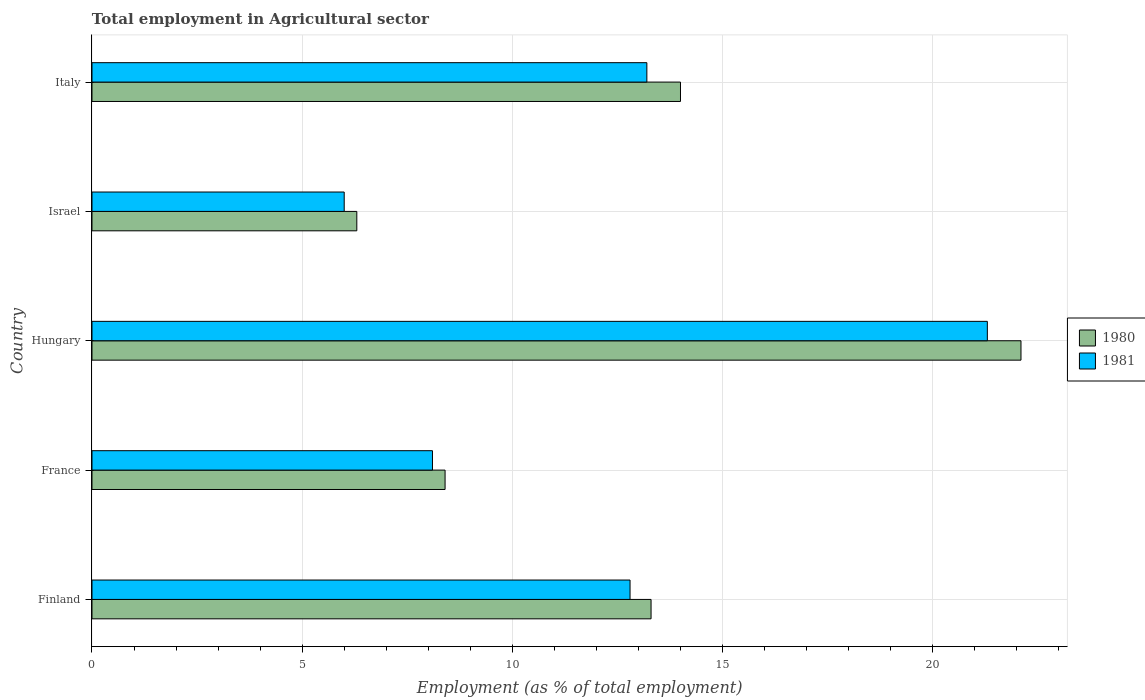How many groups of bars are there?
Your answer should be very brief. 5. Are the number of bars on each tick of the Y-axis equal?
Your answer should be very brief. Yes. What is the label of the 3rd group of bars from the top?
Provide a succinct answer. Hungary. What is the employment in agricultural sector in 1981 in Finland?
Offer a terse response. 12.8. Across all countries, what is the maximum employment in agricultural sector in 1980?
Provide a short and direct response. 22.1. Across all countries, what is the minimum employment in agricultural sector in 1981?
Your response must be concise. 6. In which country was the employment in agricultural sector in 1981 maximum?
Ensure brevity in your answer.  Hungary. What is the total employment in agricultural sector in 1980 in the graph?
Provide a short and direct response. 64.1. What is the difference between the employment in agricultural sector in 1980 in Finland and that in Italy?
Provide a succinct answer. -0.7. What is the difference between the employment in agricultural sector in 1980 in Israel and the employment in agricultural sector in 1981 in France?
Provide a short and direct response. -1.8. What is the average employment in agricultural sector in 1981 per country?
Offer a very short reply. 12.28. What is the difference between the employment in agricultural sector in 1981 and employment in agricultural sector in 1980 in Hungary?
Make the answer very short. -0.8. What is the ratio of the employment in agricultural sector in 1980 in Finland to that in France?
Keep it short and to the point. 1.58. Is the difference between the employment in agricultural sector in 1981 in Finland and Italy greater than the difference between the employment in agricultural sector in 1980 in Finland and Italy?
Offer a terse response. Yes. What is the difference between the highest and the second highest employment in agricultural sector in 1981?
Make the answer very short. 8.1. What is the difference between the highest and the lowest employment in agricultural sector in 1981?
Your answer should be very brief. 15.3. In how many countries, is the employment in agricultural sector in 1981 greater than the average employment in agricultural sector in 1981 taken over all countries?
Offer a terse response. 3. What does the 1st bar from the top in Finland represents?
Your answer should be very brief. 1981. Are all the bars in the graph horizontal?
Give a very brief answer. Yes. How many countries are there in the graph?
Your answer should be very brief. 5. Does the graph contain any zero values?
Your answer should be very brief. No. Does the graph contain grids?
Keep it short and to the point. Yes. How are the legend labels stacked?
Provide a short and direct response. Vertical. What is the title of the graph?
Offer a very short reply. Total employment in Agricultural sector. What is the label or title of the X-axis?
Make the answer very short. Employment (as % of total employment). What is the Employment (as % of total employment) of 1980 in Finland?
Offer a terse response. 13.3. What is the Employment (as % of total employment) in 1981 in Finland?
Give a very brief answer. 12.8. What is the Employment (as % of total employment) of 1980 in France?
Your answer should be compact. 8.4. What is the Employment (as % of total employment) of 1981 in France?
Make the answer very short. 8.1. What is the Employment (as % of total employment) of 1980 in Hungary?
Give a very brief answer. 22.1. What is the Employment (as % of total employment) of 1981 in Hungary?
Keep it short and to the point. 21.3. What is the Employment (as % of total employment) of 1980 in Israel?
Offer a very short reply. 6.3. What is the Employment (as % of total employment) in 1981 in Israel?
Your answer should be compact. 6. What is the Employment (as % of total employment) in 1980 in Italy?
Give a very brief answer. 14. What is the Employment (as % of total employment) in 1981 in Italy?
Give a very brief answer. 13.2. Across all countries, what is the maximum Employment (as % of total employment) in 1980?
Give a very brief answer. 22.1. Across all countries, what is the maximum Employment (as % of total employment) in 1981?
Your answer should be compact. 21.3. Across all countries, what is the minimum Employment (as % of total employment) of 1980?
Your answer should be compact. 6.3. What is the total Employment (as % of total employment) of 1980 in the graph?
Your response must be concise. 64.1. What is the total Employment (as % of total employment) of 1981 in the graph?
Your answer should be very brief. 61.4. What is the difference between the Employment (as % of total employment) of 1981 in Finland and that in Hungary?
Offer a very short reply. -8.5. What is the difference between the Employment (as % of total employment) in 1980 in Finland and that in Israel?
Give a very brief answer. 7. What is the difference between the Employment (as % of total employment) of 1980 in France and that in Hungary?
Offer a very short reply. -13.7. What is the difference between the Employment (as % of total employment) of 1981 in France and that in Hungary?
Offer a terse response. -13.2. What is the difference between the Employment (as % of total employment) of 1981 in France and that in Israel?
Your answer should be compact. 2.1. What is the difference between the Employment (as % of total employment) of 1980 in Hungary and that in Israel?
Ensure brevity in your answer.  15.8. What is the difference between the Employment (as % of total employment) of 1980 in Hungary and that in Italy?
Offer a very short reply. 8.1. What is the difference between the Employment (as % of total employment) in 1980 in Israel and that in Italy?
Provide a short and direct response. -7.7. What is the difference between the Employment (as % of total employment) in 1980 in Finland and the Employment (as % of total employment) in 1981 in France?
Give a very brief answer. 5.2. What is the difference between the Employment (as % of total employment) of 1980 in Finland and the Employment (as % of total employment) of 1981 in Hungary?
Your response must be concise. -8. What is the difference between the Employment (as % of total employment) of 1980 in Finland and the Employment (as % of total employment) of 1981 in Israel?
Provide a succinct answer. 7.3. What is the difference between the Employment (as % of total employment) in 1980 in France and the Employment (as % of total employment) in 1981 in Hungary?
Make the answer very short. -12.9. What is the difference between the Employment (as % of total employment) in 1980 in France and the Employment (as % of total employment) in 1981 in Israel?
Keep it short and to the point. 2.4. What is the difference between the Employment (as % of total employment) of 1980 in France and the Employment (as % of total employment) of 1981 in Italy?
Provide a short and direct response. -4.8. What is the difference between the Employment (as % of total employment) of 1980 in Hungary and the Employment (as % of total employment) of 1981 in Israel?
Your response must be concise. 16.1. What is the difference between the Employment (as % of total employment) in 1980 in Hungary and the Employment (as % of total employment) in 1981 in Italy?
Provide a succinct answer. 8.9. What is the difference between the Employment (as % of total employment) of 1980 in Israel and the Employment (as % of total employment) of 1981 in Italy?
Provide a short and direct response. -6.9. What is the average Employment (as % of total employment) of 1980 per country?
Provide a short and direct response. 12.82. What is the average Employment (as % of total employment) in 1981 per country?
Provide a short and direct response. 12.28. What is the difference between the Employment (as % of total employment) of 1980 and Employment (as % of total employment) of 1981 in Finland?
Offer a terse response. 0.5. What is the difference between the Employment (as % of total employment) of 1980 and Employment (as % of total employment) of 1981 in Hungary?
Your response must be concise. 0.8. What is the ratio of the Employment (as % of total employment) in 1980 in Finland to that in France?
Ensure brevity in your answer.  1.58. What is the ratio of the Employment (as % of total employment) in 1981 in Finland to that in France?
Provide a short and direct response. 1.58. What is the ratio of the Employment (as % of total employment) of 1980 in Finland to that in Hungary?
Offer a very short reply. 0.6. What is the ratio of the Employment (as % of total employment) in 1981 in Finland to that in Hungary?
Make the answer very short. 0.6. What is the ratio of the Employment (as % of total employment) in 1980 in Finland to that in Israel?
Your response must be concise. 2.11. What is the ratio of the Employment (as % of total employment) in 1981 in Finland to that in Israel?
Offer a very short reply. 2.13. What is the ratio of the Employment (as % of total employment) of 1980 in Finland to that in Italy?
Your answer should be very brief. 0.95. What is the ratio of the Employment (as % of total employment) of 1981 in Finland to that in Italy?
Provide a succinct answer. 0.97. What is the ratio of the Employment (as % of total employment) in 1980 in France to that in Hungary?
Your response must be concise. 0.38. What is the ratio of the Employment (as % of total employment) of 1981 in France to that in Hungary?
Ensure brevity in your answer.  0.38. What is the ratio of the Employment (as % of total employment) of 1980 in France to that in Israel?
Ensure brevity in your answer.  1.33. What is the ratio of the Employment (as % of total employment) of 1981 in France to that in Israel?
Provide a succinct answer. 1.35. What is the ratio of the Employment (as % of total employment) of 1981 in France to that in Italy?
Your response must be concise. 0.61. What is the ratio of the Employment (as % of total employment) in 1980 in Hungary to that in Israel?
Offer a very short reply. 3.51. What is the ratio of the Employment (as % of total employment) of 1981 in Hungary to that in Israel?
Make the answer very short. 3.55. What is the ratio of the Employment (as % of total employment) of 1980 in Hungary to that in Italy?
Provide a short and direct response. 1.58. What is the ratio of the Employment (as % of total employment) in 1981 in Hungary to that in Italy?
Your response must be concise. 1.61. What is the ratio of the Employment (as % of total employment) of 1980 in Israel to that in Italy?
Offer a terse response. 0.45. What is the ratio of the Employment (as % of total employment) of 1981 in Israel to that in Italy?
Your answer should be compact. 0.45. What is the difference between the highest and the second highest Employment (as % of total employment) in 1980?
Keep it short and to the point. 8.1. What is the difference between the highest and the second highest Employment (as % of total employment) of 1981?
Provide a succinct answer. 8.1. What is the difference between the highest and the lowest Employment (as % of total employment) of 1981?
Keep it short and to the point. 15.3. 